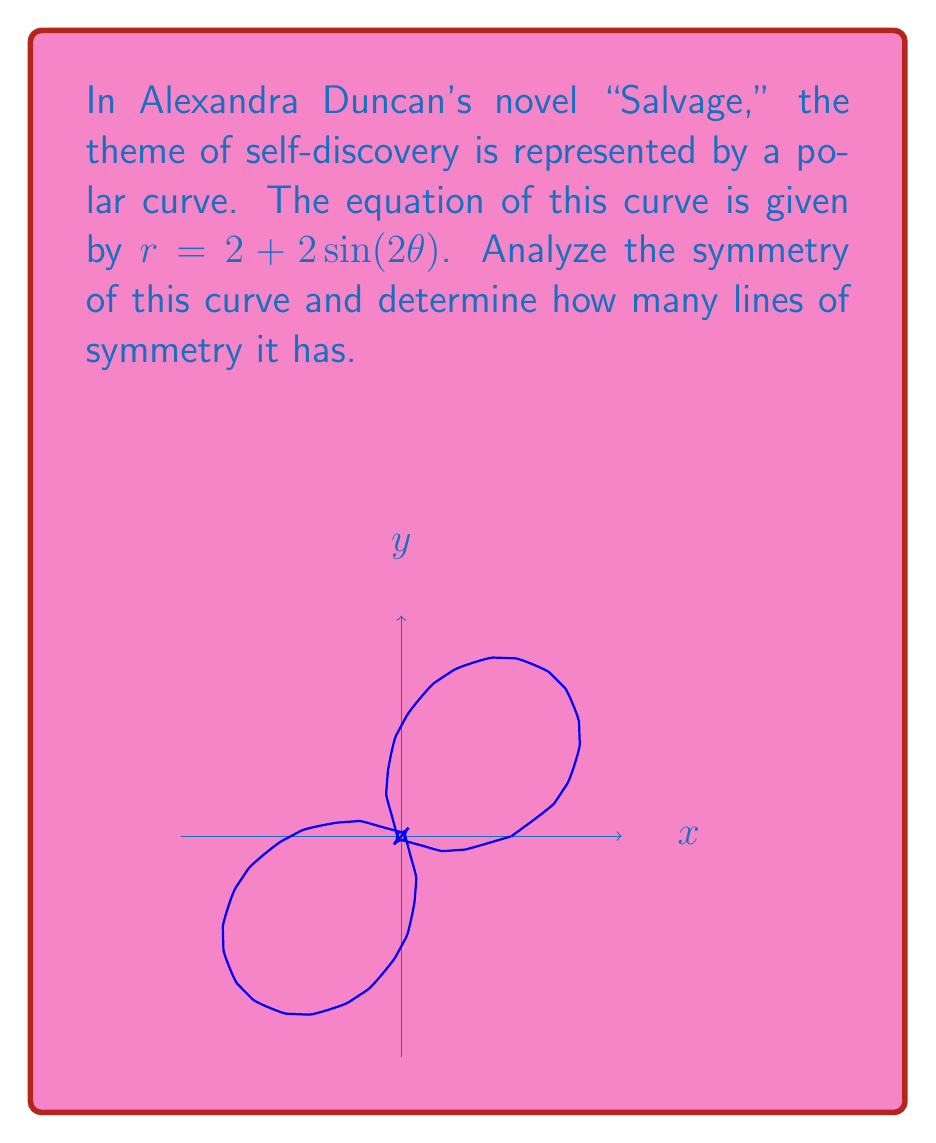What is the answer to this math problem? To analyze the symmetry of the polar curve $r = 2 + 2\sin(2\theta)$, we need to follow these steps:

1) First, recall that for a polar curve to have symmetry about the x-axis, $r(\theta) = r(-\theta)$. For y-axis symmetry, $r(\theta) = -r(\pi-\theta)$.

2) For x-axis symmetry:
   $r(\theta) = 2 + 2\sin(2\theta)$
   $r(-\theta) = 2 + 2\sin(-2\theta) = 2 - 2\sin(2\theta)$
   These are not equal, so there's no x-axis symmetry.

3) For y-axis symmetry:
   $r(\theta) = 2 + 2\sin(2\theta)$
   $-r(\pi-\theta) = -(2 + 2\sin(2(\pi-\theta))) = -(2 + 2\sin(2\pi-2\theta)) = -(2 - 2\sin(2\theta)) = -2 + 2\sin(2\theta)$
   These are not equal, so there's no y-axis symmetry.

4) However, notice that $\sin(2\theta)$ has a period of $\pi$. This means the curve repeats every $\pi$ radians.

5) Moreover, $\sin(2\theta) = \sin(2(\theta+\pi))$, which means the curve is symmetric about the pole (origin).

6) The curve also has symmetry about the lines $\theta = \frac{\pi}{4}$ and $\theta = \frac{3\pi}{4}$. This is because $\sin(2(\frac{\pi}{4}+\theta)) = \sin(2(\frac{\pi}{4}-\theta))$ and $\sin(2(\frac{3\pi}{4}+\theta)) = \sin(2(\frac{3\pi}{4}-\theta))$.

Therefore, the curve has 2 lines of symmetry: $\theta = \frac{\pi}{4}$ and $\theta = \frac{3\pi}{4}$.
Answer: 2 lines of symmetry 